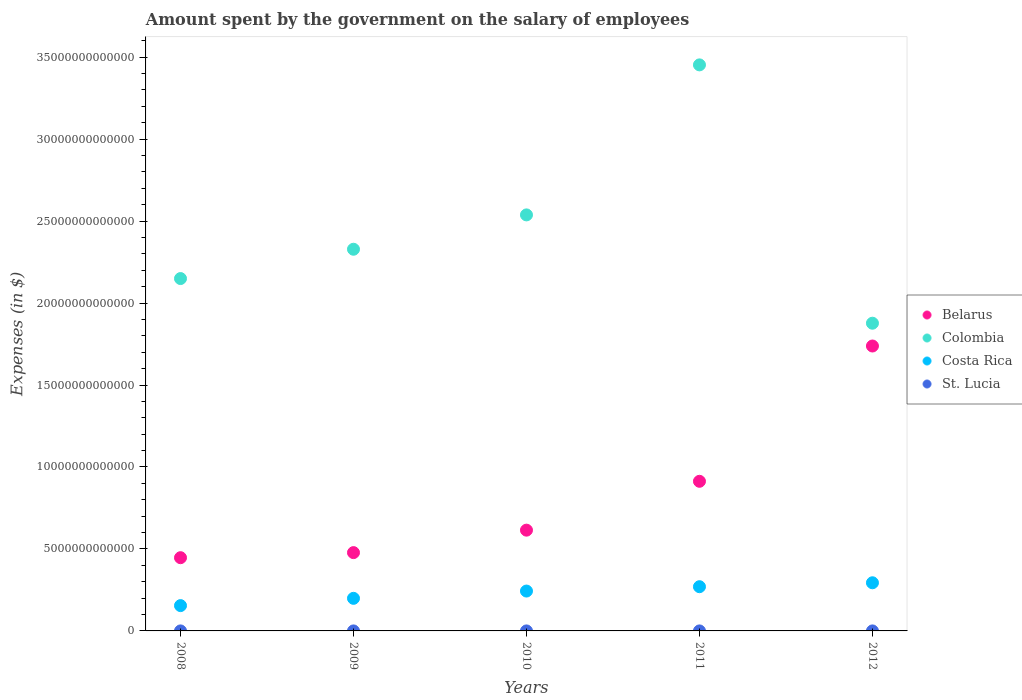Is the number of dotlines equal to the number of legend labels?
Your answer should be very brief. Yes. What is the amount spent on the salary of employees by the government in St. Lucia in 2009?
Your answer should be compact. 3.09e+08. Across all years, what is the maximum amount spent on the salary of employees by the government in Belarus?
Make the answer very short. 1.74e+13. Across all years, what is the minimum amount spent on the salary of employees by the government in Colombia?
Make the answer very short. 1.88e+13. In which year was the amount spent on the salary of employees by the government in Colombia maximum?
Give a very brief answer. 2011. In which year was the amount spent on the salary of employees by the government in St. Lucia minimum?
Offer a very short reply. 2008. What is the total amount spent on the salary of employees by the government in Belarus in the graph?
Keep it short and to the point. 4.19e+13. What is the difference between the amount spent on the salary of employees by the government in St. Lucia in 2011 and that in 2012?
Give a very brief answer. -1.37e+07. What is the difference between the amount spent on the salary of employees by the government in Colombia in 2012 and the amount spent on the salary of employees by the government in St. Lucia in 2008?
Keep it short and to the point. 1.88e+13. What is the average amount spent on the salary of employees by the government in Belarus per year?
Make the answer very short. 8.38e+12. In the year 2012, what is the difference between the amount spent on the salary of employees by the government in Costa Rica and amount spent on the salary of employees by the government in Colombia?
Your answer should be compact. -1.58e+13. In how many years, is the amount spent on the salary of employees by the government in Colombia greater than 9000000000000 $?
Your answer should be compact. 5. What is the ratio of the amount spent on the salary of employees by the government in Belarus in 2008 to that in 2009?
Your answer should be compact. 0.94. What is the difference between the highest and the second highest amount spent on the salary of employees by the government in Belarus?
Provide a short and direct response. 8.25e+12. What is the difference between the highest and the lowest amount spent on the salary of employees by the government in St. Lucia?
Make the answer very short. 7.08e+07. Is the sum of the amount spent on the salary of employees by the government in Belarus in 2008 and 2011 greater than the maximum amount spent on the salary of employees by the government in Colombia across all years?
Your answer should be compact. No. Is it the case that in every year, the sum of the amount spent on the salary of employees by the government in Costa Rica and amount spent on the salary of employees by the government in Belarus  is greater than the sum of amount spent on the salary of employees by the government in Colombia and amount spent on the salary of employees by the government in St. Lucia?
Offer a terse response. No. Is the amount spent on the salary of employees by the government in Belarus strictly less than the amount spent on the salary of employees by the government in St. Lucia over the years?
Keep it short and to the point. No. What is the difference between two consecutive major ticks on the Y-axis?
Make the answer very short. 5.00e+12. Does the graph contain grids?
Provide a short and direct response. No. How are the legend labels stacked?
Offer a very short reply. Vertical. What is the title of the graph?
Your answer should be compact. Amount spent by the government on the salary of employees. Does "Romania" appear as one of the legend labels in the graph?
Your answer should be very brief. No. What is the label or title of the X-axis?
Offer a very short reply. Years. What is the label or title of the Y-axis?
Your response must be concise. Expenses (in $). What is the Expenses (in $) of Belarus in 2008?
Your answer should be very brief. 4.47e+12. What is the Expenses (in $) of Colombia in 2008?
Your answer should be compact. 2.15e+13. What is the Expenses (in $) of Costa Rica in 2008?
Your answer should be very brief. 1.54e+12. What is the Expenses (in $) of St. Lucia in 2008?
Offer a very short reply. 2.88e+08. What is the Expenses (in $) in Belarus in 2009?
Ensure brevity in your answer.  4.78e+12. What is the Expenses (in $) of Colombia in 2009?
Give a very brief answer. 2.33e+13. What is the Expenses (in $) in Costa Rica in 2009?
Provide a succinct answer. 1.99e+12. What is the Expenses (in $) in St. Lucia in 2009?
Your answer should be very brief. 3.09e+08. What is the Expenses (in $) of Belarus in 2010?
Provide a succinct answer. 6.15e+12. What is the Expenses (in $) in Colombia in 2010?
Your response must be concise. 2.54e+13. What is the Expenses (in $) in Costa Rica in 2010?
Ensure brevity in your answer.  2.43e+12. What is the Expenses (in $) in St. Lucia in 2010?
Offer a very short reply. 3.37e+08. What is the Expenses (in $) of Belarus in 2011?
Offer a terse response. 9.13e+12. What is the Expenses (in $) in Colombia in 2011?
Offer a terse response. 3.45e+13. What is the Expenses (in $) of Costa Rica in 2011?
Provide a succinct answer. 2.70e+12. What is the Expenses (in $) of St. Lucia in 2011?
Provide a short and direct response. 3.45e+08. What is the Expenses (in $) of Belarus in 2012?
Make the answer very short. 1.74e+13. What is the Expenses (in $) of Colombia in 2012?
Offer a terse response. 1.88e+13. What is the Expenses (in $) of Costa Rica in 2012?
Give a very brief answer. 2.94e+12. What is the Expenses (in $) of St. Lucia in 2012?
Your response must be concise. 3.59e+08. Across all years, what is the maximum Expenses (in $) of Belarus?
Make the answer very short. 1.74e+13. Across all years, what is the maximum Expenses (in $) of Colombia?
Make the answer very short. 3.45e+13. Across all years, what is the maximum Expenses (in $) of Costa Rica?
Make the answer very short. 2.94e+12. Across all years, what is the maximum Expenses (in $) in St. Lucia?
Offer a very short reply. 3.59e+08. Across all years, what is the minimum Expenses (in $) in Belarus?
Make the answer very short. 4.47e+12. Across all years, what is the minimum Expenses (in $) in Colombia?
Provide a short and direct response. 1.88e+13. Across all years, what is the minimum Expenses (in $) of Costa Rica?
Your response must be concise. 1.54e+12. Across all years, what is the minimum Expenses (in $) in St. Lucia?
Your response must be concise. 2.88e+08. What is the total Expenses (in $) of Belarus in the graph?
Keep it short and to the point. 4.19e+13. What is the total Expenses (in $) of Colombia in the graph?
Ensure brevity in your answer.  1.23e+14. What is the total Expenses (in $) in Costa Rica in the graph?
Make the answer very short. 1.16e+13. What is the total Expenses (in $) of St. Lucia in the graph?
Provide a succinct answer. 1.64e+09. What is the difference between the Expenses (in $) of Belarus in 2008 and that in 2009?
Provide a succinct answer. -3.10e+11. What is the difference between the Expenses (in $) in Colombia in 2008 and that in 2009?
Provide a short and direct response. -1.79e+12. What is the difference between the Expenses (in $) in Costa Rica in 2008 and that in 2009?
Keep it short and to the point. -4.44e+11. What is the difference between the Expenses (in $) in St. Lucia in 2008 and that in 2009?
Offer a very short reply. -2.07e+07. What is the difference between the Expenses (in $) of Belarus in 2008 and that in 2010?
Give a very brief answer. -1.68e+12. What is the difference between the Expenses (in $) of Colombia in 2008 and that in 2010?
Keep it short and to the point. -3.88e+12. What is the difference between the Expenses (in $) of Costa Rica in 2008 and that in 2010?
Your answer should be compact. -8.88e+11. What is the difference between the Expenses (in $) in St. Lucia in 2008 and that in 2010?
Your answer should be very brief. -4.83e+07. What is the difference between the Expenses (in $) in Belarus in 2008 and that in 2011?
Provide a short and direct response. -4.66e+12. What is the difference between the Expenses (in $) of Colombia in 2008 and that in 2011?
Give a very brief answer. -1.30e+13. What is the difference between the Expenses (in $) of Costa Rica in 2008 and that in 2011?
Your answer should be very brief. -1.15e+12. What is the difference between the Expenses (in $) of St. Lucia in 2008 and that in 2011?
Offer a very short reply. -5.71e+07. What is the difference between the Expenses (in $) of Belarus in 2008 and that in 2012?
Offer a very short reply. -1.29e+13. What is the difference between the Expenses (in $) of Colombia in 2008 and that in 2012?
Your answer should be very brief. 2.72e+12. What is the difference between the Expenses (in $) of Costa Rica in 2008 and that in 2012?
Your response must be concise. -1.39e+12. What is the difference between the Expenses (in $) in St. Lucia in 2008 and that in 2012?
Offer a terse response. -7.08e+07. What is the difference between the Expenses (in $) in Belarus in 2009 and that in 2010?
Provide a short and direct response. -1.37e+12. What is the difference between the Expenses (in $) of Colombia in 2009 and that in 2010?
Offer a very short reply. -2.09e+12. What is the difference between the Expenses (in $) of Costa Rica in 2009 and that in 2010?
Your answer should be compact. -4.44e+11. What is the difference between the Expenses (in $) of St. Lucia in 2009 and that in 2010?
Your answer should be very brief. -2.76e+07. What is the difference between the Expenses (in $) of Belarus in 2009 and that in 2011?
Your answer should be compact. -4.35e+12. What is the difference between the Expenses (in $) in Colombia in 2009 and that in 2011?
Offer a very short reply. -1.12e+13. What is the difference between the Expenses (in $) in Costa Rica in 2009 and that in 2011?
Give a very brief answer. -7.10e+11. What is the difference between the Expenses (in $) in St. Lucia in 2009 and that in 2011?
Your answer should be compact. -3.64e+07. What is the difference between the Expenses (in $) in Belarus in 2009 and that in 2012?
Offer a very short reply. -1.26e+13. What is the difference between the Expenses (in $) in Colombia in 2009 and that in 2012?
Make the answer very short. 4.51e+12. What is the difference between the Expenses (in $) of Costa Rica in 2009 and that in 2012?
Make the answer very short. -9.49e+11. What is the difference between the Expenses (in $) in St. Lucia in 2009 and that in 2012?
Provide a short and direct response. -5.01e+07. What is the difference between the Expenses (in $) of Belarus in 2010 and that in 2011?
Your answer should be compact. -2.98e+12. What is the difference between the Expenses (in $) in Colombia in 2010 and that in 2011?
Give a very brief answer. -9.15e+12. What is the difference between the Expenses (in $) of Costa Rica in 2010 and that in 2011?
Your response must be concise. -2.65e+11. What is the difference between the Expenses (in $) in St. Lucia in 2010 and that in 2011?
Provide a succinct answer. -8.80e+06. What is the difference between the Expenses (in $) of Belarus in 2010 and that in 2012?
Your answer should be compact. -1.12e+13. What is the difference between the Expenses (in $) of Colombia in 2010 and that in 2012?
Your answer should be compact. 6.61e+12. What is the difference between the Expenses (in $) of Costa Rica in 2010 and that in 2012?
Ensure brevity in your answer.  -5.05e+11. What is the difference between the Expenses (in $) of St. Lucia in 2010 and that in 2012?
Make the answer very short. -2.25e+07. What is the difference between the Expenses (in $) of Belarus in 2011 and that in 2012?
Your answer should be very brief. -8.25e+12. What is the difference between the Expenses (in $) in Colombia in 2011 and that in 2012?
Your response must be concise. 1.58e+13. What is the difference between the Expenses (in $) in Costa Rica in 2011 and that in 2012?
Provide a short and direct response. -2.40e+11. What is the difference between the Expenses (in $) of St. Lucia in 2011 and that in 2012?
Keep it short and to the point. -1.37e+07. What is the difference between the Expenses (in $) of Belarus in 2008 and the Expenses (in $) of Colombia in 2009?
Your response must be concise. -1.88e+13. What is the difference between the Expenses (in $) in Belarus in 2008 and the Expenses (in $) in Costa Rica in 2009?
Offer a very short reply. 2.48e+12. What is the difference between the Expenses (in $) in Belarus in 2008 and the Expenses (in $) in St. Lucia in 2009?
Provide a short and direct response. 4.47e+12. What is the difference between the Expenses (in $) in Colombia in 2008 and the Expenses (in $) in Costa Rica in 2009?
Offer a terse response. 1.95e+13. What is the difference between the Expenses (in $) of Colombia in 2008 and the Expenses (in $) of St. Lucia in 2009?
Your answer should be very brief. 2.15e+13. What is the difference between the Expenses (in $) in Costa Rica in 2008 and the Expenses (in $) in St. Lucia in 2009?
Offer a terse response. 1.54e+12. What is the difference between the Expenses (in $) in Belarus in 2008 and the Expenses (in $) in Colombia in 2010?
Offer a terse response. -2.09e+13. What is the difference between the Expenses (in $) of Belarus in 2008 and the Expenses (in $) of Costa Rica in 2010?
Offer a terse response. 2.03e+12. What is the difference between the Expenses (in $) in Belarus in 2008 and the Expenses (in $) in St. Lucia in 2010?
Offer a terse response. 4.47e+12. What is the difference between the Expenses (in $) in Colombia in 2008 and the Expenses (in $) in Costa Rica in 2010?
Ensure brevity in your answer.  1.91e+13. What is the difference between the Expenses (in $) of Colombia in 2008 and the Expenses (in $) of St. Lucia in 2010?
Your answer should be very brief. 2.15e+13. What is the difference between the Expenses (in $) of Costa Rica in 2008 and the Expenses (in $) of St. Lucia in 2010?
Make the answer very short. 1.54e+12. What is the difference between the Expenses (in $) of Belarus in 2008 and the Expenses (in $) of Colombia in 2011?
Give a very brief answer. -3.01e+13. What is the difference between the Expenses (in $) of Belarus in 2008 and the Expenses (in $) of Costa Rica in 2011?
Your response must be concise. 1.77e+12. What is the difference between the Expenses (in $) in Belarus in 2008 and the Expenses (in $) in St. Lucia in 2011?
Offer a very short reply. 4.47e+12. What is the difference between the Expenses (in $) in Colombia in 2008 and the Expenses (in $) in Costa Rica in 2011?
Make the answer very short. 1.88e+13. What is the difference between the Expenses (in $) of Colombia in 2008 and the Expenses (in $) of St. Lucia in 2011?
Your answer should be very brief. 2.15e+13. What is the difference between the Expenses (in $) of Costa Rica in 2008 and the Expenses (in $) of St. Lucia in 2011?
Offer a terse response. 1.54e+12. What is the difference between the Expenses (in $) of Belarus in 2008 and the Expenses (in $) of Colombia in 2012?
Your answer should be compact. -1.43e+13. What is the difference between the Expenses (in $) in Belarus in 2008 and the Expenses (in $) in Costa Rica in 2012?
Provide a succinct answer. 1.53e+12. What is the difference between the Expenses (in $) in Belarus in 2008 and the Expenses (in $) in St. Lucia in 2012?
Your response must be concise. 4.47e+12. What is the difference between the Expenses (in $) of Colombia in 2008 and the Expenses (in $) of Costa Rica in 2012?
Offer a very short reply. 1.86e+13. What is the difference between the Expenses (in $) in Colombia in 2008 and the Expenses (in $) in St. Lucia in 2012?
Your answer should be compact. 2.15e+13. What is the difference between the Expenses (in $) of Costa Rica in 2008 and the Expenses (in $) of St. Lucia in 2012?
Ensure brevity in your answer.  1.54e+12. What is the difference between the Expenses (in $) of Belarus in 2009 and the Expenses (in $) of Colombia in 2010?
Your answer should be very brief. -2.06e+13. What is the difference between the Expenses (in $) of Belarus in 2009 and the Expenses (in $) of Costa Rica in 2010?
Your response must be concise. 2.34e+12. What is the difference between the Expenses (in $) of Belarus in 2009 and the Expenses (in $) of St. Lucia in 2010?
Keep it short and to the point. 4.78e+12. What is the difference between the Expenses (in $) in Colombia in 2009 and the Expenses (in $) in Costa Rica in 2010?
Keep it short and to the point. 2.09e+13. What is the difference between the Expenses (in $) of Colombia in 2009 and the Expenses (in $) of St. Lucia in 2010?
Offer a terse response. 2.33e+13. What is the difference between the Expenses (in $) in Costa Rica in 2009 and the Expenses (in $) in St. Lucia in 2010?
Ensure brevity in your answer.  1.99e+12. What is the difference between the Expenses (in $) of Belarus in 2009 and the Expenses (in $) of Colombia in 2011?
Your answer should be very brief. -2.98e+13. What is the difference between the Expenses (in $) of Belarus in 2009 and the Expenses (in $) of Costa Rica in 2011?
Your response must be concise. 2.08e+12. What is the difference between the Expenses (in $) in Belarus in 2009 and the Expenses (in $) in St. Lucia in 2011?
Make the answer very short. 4.78e+12. What is the difference between the Expenses (in $) of Colombia in 2009 and the Expenses (in $) of Costa Rica in 2011?
Provide a short and direct response. 2.06e+13. What is the difference between the Expenses (in $) in Colombia in 2009 and the Expenses (in $) in St. Lucia in 2011?
Keep it short and to the point. 2.33e+13. What is the difference between the Expenses (in $) of Costa Rica in 2009 and the Expenses (in $) of St. Lucia in 2011?
Your answer should be very brief. 1.99e+12. What is the difference between the Expenses (in $) of Belarus in 2009 and the Expenses (in $) of Colombia in 2012?
Make the answer very short. -1.40e+13. What is the difference between the Expenses (in $) of Belarus in 2009 and the Expenses (in $) of Costa Rica in 2012?
Your response must be concise. 1.84e+12. What is the difference between the Expenses (in $) of Belarus in 2009 and the Expenses (in $) of St. Lucia in 2012?
Your response must be concise. 4.78e+12. What is the difference between the Expenses (in $) of Colombia in 2009 and the Expenses (in $) of Costa Rica in 2012?
Offer a terse response. 2.03e+13. What is the difference between the Expenses (in $) of Colombia in 2009 and the Expenses (in $) of St. Lucia in 2012?
Your answer should be very brief. 2.33e+13. What is the difference between the Expenses (in $) of Costa Rica in 2009 and the Expenses (in $) of St. Lucia in 2012?
Ensure brevity in your answer.  1.99e+12. What is the difference between the Expenses (in $) in Belarus in 2010 and the Expenses (in $) in Colombia in 2011?
Give a very brief answer. -2.84e+13. What is the difference between the Expenses (in $) of Belarus in 2010 and the Expenses (in $) of Costa Rica in 2011?
Your answer should be very brief. 3.45e+12. What is the difference between the Expenses (in $) in Belarus in 2010 and the Expenses (in $) in St. Lucia in 2011?
Your response must be concise. 6.15e+12. What is the difference between the Expenses (in $) of Colombia in 2010 and the Expenses (in $) of Costa Rica in 2011?
Provide a succinct answer. 2.27e+13. What is the difference between the Expenses (in $) of Colombia in 2010 and the Expenses (in $) of St. Lucia in 2011?
Make the answer very short. 2.54e+13. What is the difference between the Expenses (in $) in Costa Rica in 2010 and the Expenses (in $) in St. Lucia in 2011?
Ensure brevity in your answer.  2.43e+12. What is the difference between the Expenses (in $) in Belarus in 2010 and the Expenses (in $) in Colombia in 2012?
Your answer should be very brief. -1.26e+13. What is the difference between the Expenses (in $) of Belarus in 2010 and the Expenses (in $) of Costa Rica in 2012?
Provide a short and direct response. 3.21e+12. What is the difference between the Expenses (in $) of Belarus in 2010 and the Expenses (in $) of St. Lucia in 2012?
Provide a short and direct response. 6.15e+12. What is the difference between the Expenses (in $) of Colombia in 2010 and the Expenses (in $) of Costa Rica in 2012?
Keep it short and to the point. 2.24e+13. What is the difference between the Expenses (in $) of Colombia in 2010 and the Expenses (in $) of St. Lucia in 2012?
Provide a short and direct response. 2.54e+13. What is the difference between the Expenses (in $) in Costa Rica in 2010 and the Expenses (in $) in St. Lucia in 2012?
Give a very brief answer. 2.43e+12. What is the difference between the Expenses (in $) of Belarus in 2011 and the Expenses (in $) of Colombia in 2012?
Your answer should be compact. -9.64e+12. What is the difference between the Expenses (in $) in Belarus in 2011 and the Expenses (in $) in Costa Rica in 2012?
Provide a succinct answer. 6.19e+12. What is the difference between the Expenses (in $) of Belarus in 2011 and the Expenses (in $) of St. Lucia in 2012?
Make the answer very short. 9.13e+12. What is the difference between the Expenses (in $) of Colombia in 2011 and the Expenses (in $) of Costa Rica in 2012?
Give a very brief answer. 3.16e+13. What is the difference between the Expenses (in $) of Colombia in 2011 and the Expenses (in $) of St. Lucia in 2012?
Keep it short and to the point. 3.45e+13. What is the difference between the Expenses (in $) in Costa Rica in 2011 and the Expenses (in $) in St. Lucia in 2012?
Offer a terse response. 2.70e+12. What is the average Expenses (in $) in Belarus per year?
Your answer should be compact. 8.38e+12. What is the average Expenses (in $) of Colombia per year?
Ensure brevity in your answer.  2.47e+13. What is the average Expenses (in $) in Costa Rica per year?
Your response must be concise. 2.32e+12. What is the average Expenses (in $) in St. Lucia per year?
Ensure brevity in your answer.  3.28e+08. In the year 2008, what is the difference between the Expenses (in $) in Belarus and Expenses (in $) in Colombia?
Provide a short and direct response. -1.70e+13. In the year 2008, what is the difference between the Expenses (in $) of Belarus and Expenses (in $) of Costa Rica?
Make the answer very short. 2.92e+12. In the year 2008, what is the difference between the Expenses (in $) in Belarus and Expenses (in $) in St. Lucia?
Offer a terse response. 4.47e+12. In the year 2008, what is the difference between the Expenses (in $) in Colombia and Expenses (in $) in Costa Rica?
Your response must be concise. 2.00e+13. In the year 2008, what is the difference between the Expenses (in $) in Colombia and Expenses (in $) in St. Lucia?
Offer a terse response. 2.15e+13. In the year 2008, what is the difference between the Expenses (in $) in Costa Rica and Expenses (in $) in St. Lucia?
Your response must be concise. 1.54e+12. In the year 2009, what is the difference between the Expenses (in $) in Belarus and Expenses (in $) in Colombia?
Your response must be concise. -1.85e+13. In the year 2009, what is the difference between the Expenses (in $) in Belarus and Expenses (in $) in Costa Rica?
Keep it short and to the point. 2.79e+12. In the year 2009, what is the difference between the Expenses (in $) of Belarus and Expenses (in $) of St. Lucia?
Ensure brevity in your answer.  4.78e+12. In the year 2009, what is the difference between the Expenses (in $) in Colombia and Expenses (in $) in Costa Rica?
Offer a terse response. 2.13e+13. In the year 2009, what is the difference between the Expenses (in $) of Colombia and Expenses (in $) of St. Lucia?
Provide a short and direct response. 2.33e+13. In the year 2009, what is the difference between the Expenses (in $) in Costa Rica and Expenses (in $) in St. Lucia?
Ensure brevity in your answer.  1.99e+12. In the year 2010, what is the difference between the Expenses (in $) of Belarus and Expenses (in $) of Colombia?
Make the answer very short. -1.92e+13. In the year 2010, what is the difference between the Expenses (in $) of Belarus and Expenses (in $) of Costa Rica?
Offer a very short reply. 3.71e+12. In the year 2010, what is the difference between the Expenses (in $) of Belarus and Expenses (in $) of St. Lucia?
Give a very brief answer. 6.15e+12. In the year 2010, what is the difference between the Expenses (in $) of Colombia and Expenses (in $) of Costa Rica?
Provide a short and direct response. 2.29e+13. In the year 2010, what is the difference between the Expenses (in $) of Colombia and Expenses (in $) of St. Lucia?
Your response must be concise. 2.54e+13. In the year 2010, what is the difference between the Expenses (in $) in Costa Rica and Expenses (in $) in St. Lucia?
Your answer should be compact. 2.43e+12. In the year 2011, what is the difference between the Expenses (in $) of Belarus and Expenses (in $) of Colombia?
Provide a succinct answer. -2.54e+13. In the year 2011, what is the difference between the Expenses (in $) of Belarus and Expenses (in $) of Costa Rica?
Your response must be concise. 6.43e+12. In the year 2011, what is the difference between the Expenses (in $) of Belarus and Expenses (in $) of St. Lucia?
Offer a very short reply. 9.13e+12. In the year 2011, what is the difference between the Expenses (in $) in Colombia and Expenses (in $) in Costa Rica?
Provide a short and direct response. 3.18e+13. In the year 2011, what is the difference between the Expenses (in $) of Colombia and Expenses (in $) of St. Lucia?
Your answer should be compact. 3.45e+13. In the year 2011, what is the difference between the Expenses (in $) in Costa Rica and Expenses (in $) in St. Lucia?
Your response must be concise. 2.70e+12. In the year 2012, what is the difference between the Expenses (in $) in Belarus and Expenses (in $) in Colombia?
Your response must be concise. -1.39e+12. In the year 2012, what is the difference between the Expenses (in $) in Belarus and Expenses (in $) in Costa Rica?
Keep it short and to the point. 1.44e+13. In the year 2012, what is the difference between the Expenses (in $) of Belarus and Expenses (in $) of St. Lucia?
Give a very brief answer. 1.74e+13. In the year 2012, what is the difference between the Expenses (in $) in Colombia and Expenses (in $) in Costa Rica?
Make the answer very short. 1.58e+13. In the year 2012, what is the difference between the Expenses (in $) of Colombia and Expenses (in $) of St. Lucia?
Offer a terse response. 1.88e+13. In the year 2012, what is the difference between the Expenses (in $) of Costa Rica and Expenses (in $) of St. Lucia?
Give a very brief answer. 2.94e+12. What is the ratio of the Expenses (in $) of Belarus in 2008 to that in 2009?
Your answer should be compact. 0.94. What is the ratio of the Expenses (in $) of Colombia in 2008 to that in 2009?
Your answer should be very brief. 0.92. What is the ratio of the Expenses (in $) in Costa Rica in 2008 to that in 2009?
Ensure brevity in your answer.  0.78. What is the ratio of the Expenses (in $) in St. Lucia in 2008 to that in 2009?
Your response must be concise. 0.93. What is the ratio of the Expenses (in $) in Belarus in 2008 to that in 2010?
Your answer should be compact. 0.73. What is the ratio of the Expenses (in $) in Colombia in 2008 to that in 2010?
Offer a terse response. 0.85. What is the ratio of the Expenses (in $) of Costa Rica in 2008 to that in 2010?
Keep it short and to the point. 0.63. What is the ratio of the Expenses (in $) of St. Lucia in 2008 to that in 2010?
Ensure brevity in your answer.  0.86. What is the ratio of the Expenses (in $) of Belarus in 2008 to that in 2011?
Provide a succinct answer. 0.49. What is the ratio of the Expenses (in $) in Colombia in 2008 to that in 2011?
Keep it short and to the point. 0.62. What is the ratio of the Expenses (in $) of Costa Rica in 2008 to that in 2011?
Your answer should be very brief. 0.57. What is the ratio of the Expenses (in $) of St. Lucia in 2008 to that in 2011?
Provide a succinct answer. 0.83. What is the ratio of the Expenses (in $) in Belarus in 2008 to that in 2012?
Your response must be concise. 0.26. What is the ratio of the Expenses (in $) in Colombia in 2008 to that in 2012?
Your answer should be very brief. 1.15. What is the ratio of the Expenses (in $) in Costa Rica in 2008 to that in 2012?
Your answer should be compact. 0.53. What is the ratio of the Expenses (in $) of St. Lucia in 2008 to that in 2012?
Provide a short and direct response. 0.8. What is the ratio of the Expenses (in $) in Belarus in 2009 to that in 2010?
Your answer should be very brief. 0.78. What is the ratio of the Expenses (in $) of Colombia in 2009 to that in 2010?
Keep it short and to the point. 0.92. What is the ratio of the Expenses (in $) in Costa Rica in 2009 to that in 2010?
Give a very brief answer. 0.82. What is the ratio of the Expenses (in $) in St. Lucia in 2009 to that in 2010?
Offer a very short reply. 0.92. What is the ratio of the Expenses (in $) in Belarus in 2009 to that in 2011?
Offer a terse response. 0.52. What is the ratio of the Expenses (in $) in Colombia in 2009 to that in 2011?
Offer a terse response. 0.67. What is the ratio of the Expenses (in $) in Costa Rica in 2009 to that in 2011?
Ensure brevity in your answer.  0.74. What is the ratio of the Expenses (in $) of St. Lucia in 2009 to that in 2011?
Provide a succinct answer. 0.89. What is the ratio of the Expenses (in $) of Belarus in 2009 to that in 2012?
Offer a very short reply. 0.27. What is the ratio of the Expenses (in $) in Colombia in 2009 to that in 2012?
Your answer should be compact. 1.24. What is the ratio of the Expenses (in $) of Costa Rica in 2009 to that in 2012?
Offer a very short reply. 0.68. What is the ratio of the Expenses (in $) of St. Lucia in 2009 to that in 2012?
Your answer should be compact. 0.86. What is the ratio of the Expenses (in $) in Belarus in 2010 to that in 2011?
Your response must be concise. 0.67. What is the ratio of the Expenses (in $) of Colombia in 2010 to that in 2011?
Keep it short and to the point. 0.73. What is the ratio of the Expenses (in $) in Costa Rica in 2010 to that in 2011?
Keep it short and to the point. 0.9. What is the ratio of the Expenses (in $) of St. Lucia in 2010 to that in 2011?
Provide a succinct answer. 0.97. What is the ratio of the Expenses (in $) of Belarus in 2010 to that in 2012?
Give a very brief answer. 0.35. What is the ratio of the Expenses (in $) in Colombia in 2010 to that in 2012?
Ensure brevity in your answer.  1.35. What is the ratio of the Expenses (in $) of Costa Rica in 2010 to that in 2012?
Offer a very short reply. 0.83. What is the ratio of the Expenses (in $) in St. Lucia in 2010 to that in 2012?
Your answer should be compact. 0.94. What is the ratio of the Expenses (in $) in Belarus in 2011 to that in 2012?
Make the answer very short. 0.53. What is the ratio of the Expenses (in $) in Colombia in 2011 to that in 2012?
Your response must be concise. 1.84. What is the ratio of the Expenses (in $) in Costa Rica in 2011 to that in 2012?
Provide a short and direct response. 0.92. What is the ratio of the Expenses (in $) of St. Lucia in 2011 to that in 2012?
Provide a short and direct response. 0.96. What is the difference between the highest and the second highest Expenses (in $) of Belarus?
Your answer should be compact. 8.25e+12. What is the difference between the highest and the second highest Expenses (in $) in Colombia?
Provide a succinct answer. 9.15e+12. What is the difference between the highest and the second highest Expenses (in $) of Costa Rica?
Your answer should be very brief. 2.40e+11. What is the difference between the highest and the second highest Expenses (in $) in St. Lucia?
Your answer should be compact. 1.37e+07. What is the difference between the highest and the lowest Expenses (in $) in Belarus?
Make the answer very short. 1.29e+13. What is the difference between the highest and the lowest Expenses (in $) of Colombia?
Your response must be concise. 1.58e+13. What is the difference between the highest and the lowest Expenses (in $) in Costa Rica?
Provide a short and direct response. 1.39e+12. What is the difference between the highest and the lowest Expenses (in $) in St. Lucia?
Offer a terse response. 7.08e+07. 